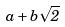Convert formula to latex. <formula><loc_0><loc_0><loc_500><loc_500>a + b \sqrt { 2 }</formula> 